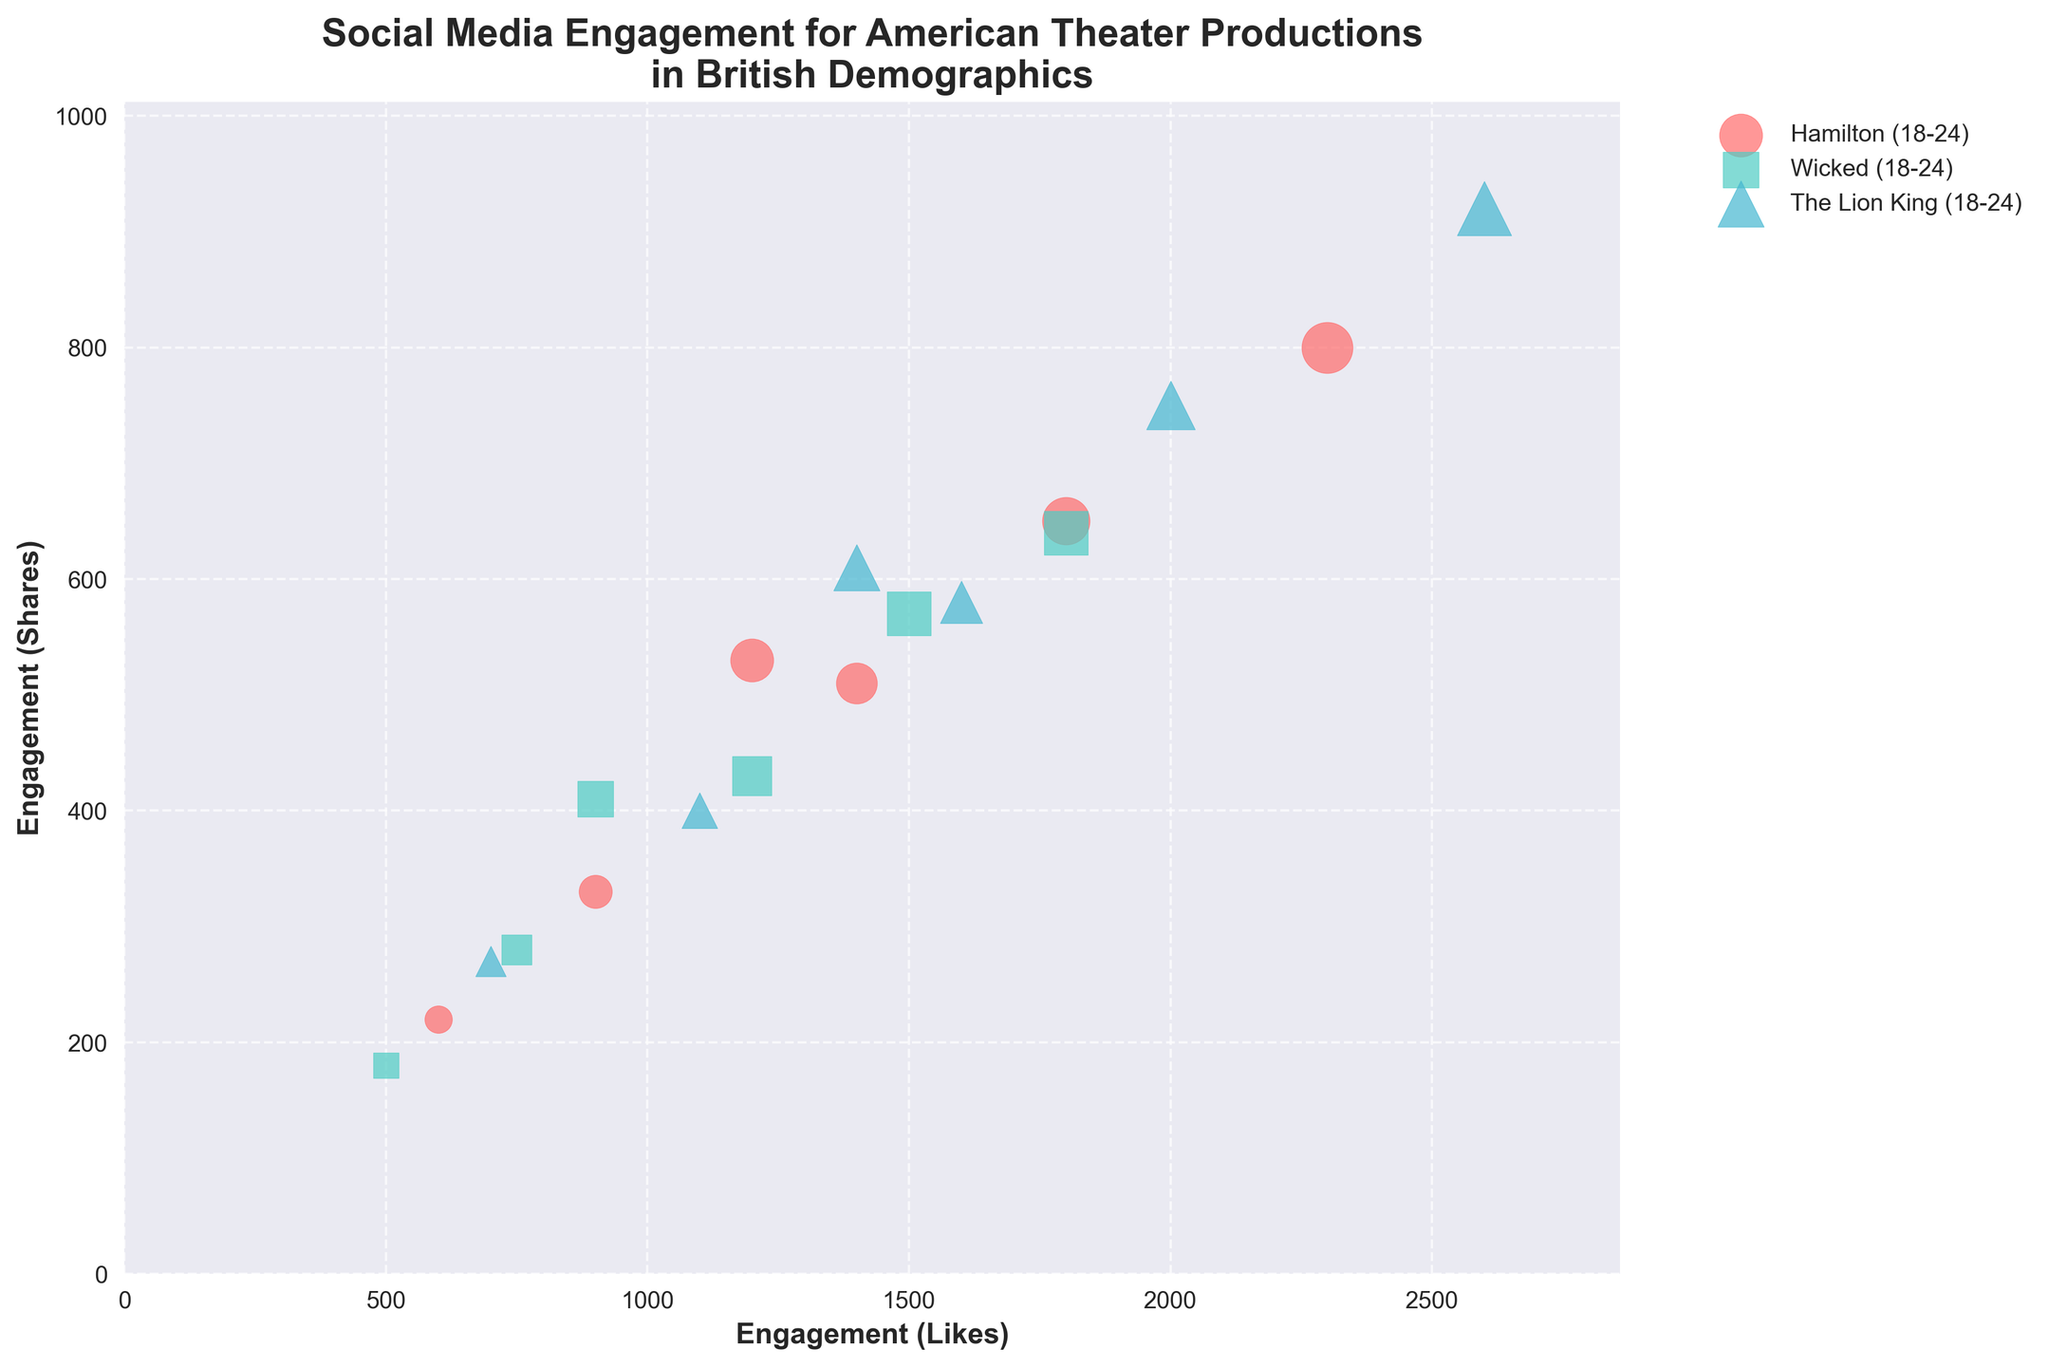What is the title of the plot? The title is the text usually located at the top of the figure. In this case, the title tells us the subject of the figure, "Social Media Engagement for American Theater Productions in British Demographics", which indicates that the plot visualizes social media interactions categorized by demographic groups for different theater productions.
Answer: Social Media Engagement for American Theater Productions in British Demographics How many demographic groups are represented in the plot? Each unique demographic group listed in the data represents a distinct group in the plot. We can count the number of unique demographic groups mentioned under "Demographic Group" to get our answer. The listed groups are 18-24, 25-34, 35-44, 45-54, 55-64, and 65+, making a total of six groups.
Answer: Six Which production has the highest engagement in terms of "Likes" for the 25-34 demographic group? By finding the data points representing the 25-34 demographic group and comparing the "Engagement (Likes)" values for each production, we see that "The Lion King" for the 25-34 demographic group has 2600 likes, which is the highest among Hamilton (2300 likes) and Wicked (1800 likes).
Answer: The Lion King Compare the total "Likes" for the 18-24 and 35-44 demographic groups. Which group has more engagement in terms of "Likes"? First, sum the likes for all productions within each demographic group:
18-24: 1200 (Hamilton) + 900 (Wicked) + 1400 (The Lion King) = 3500
35-44: 1800 (Hamilton) + 1500 (Wicked) + 2000 (The Lion King) = 5300
Comparing the sums, the 35-44 demographic group has more engagement.
Answer: 35-44 What color represents the production "Wicked" in the plot? Different productions are represented by different colors. According to the provided code, "Wicked" will have a distinct color assigned. Looking at the data and the unique identification for "Wicked," it is represented by the color green, specifically '#4ECDC4'.
Answer: Green Which demographic group has the least engagement in terms of "Shares" for the production "Hamilton"? Find the data points for "Hamilton" across all demographic groups and compare their "Engagement (Shares)" values. The data for Hamilton shows:
18-24: 530
25-34: 800
35-44: 650
45-54: 510
55-64: 330
65+: 220
The 65+ demographic group has the least engagement with 220 shares.
Answer: 65+ Determine the average number of "Comments" across all productions within the 45-54 demographic group. Average is calculated by summing up all "Comments" values for the 45-54 group and dividing by the number of productions.
Sum: 290 (Hamilton) + 260 (Wicked) + 310 (The Lion King) = 860
Number of productions: 3
Average: 860 / 3 ≈ 287
Answer: 287 Which production has a larger bubble size for the 55-64 demographic group, "Wicked" or "The Lion King"? Bubble sizes in scatter plots are often determined by another variable, here it is "Engagement (Comments)". For the 55-64 demographic group:
Wicked: 160 comments
The Lion King: 220 comments
The size of the bubble for "The Lion King" is larger due to a greater number of comments.
Answer: The Lion King How does the engagement in terms of "Likes" for "Hamilton" compare between the 18-24 and 65+ demographic groups? Compare the "Engagement (Likes)" values for "Hamilton" in the 18-24 and 65+ groups:
18-24: 1200 likes
65+: 600 likes
The 18-24 demographic group has twice as many likes compared to the 65+ group.
Answer: Twice as many 